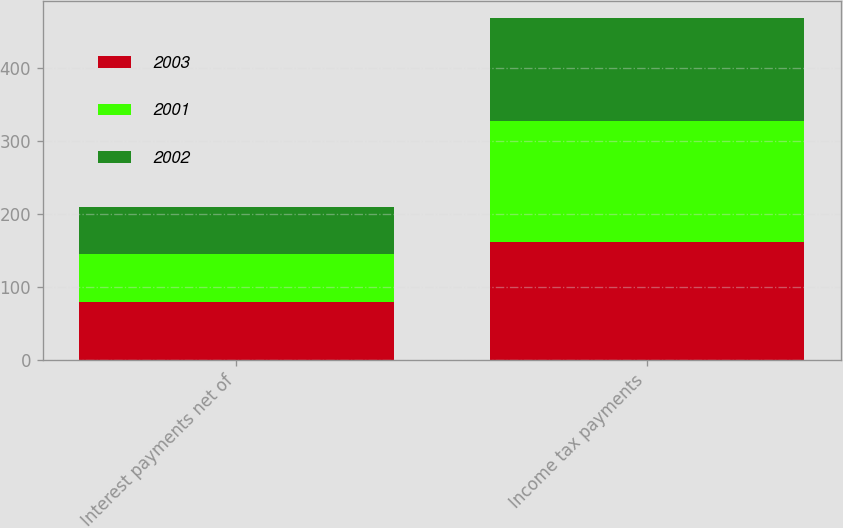<chart> <loc_0><loc_0><loc_500><loc_500><stacked_bar_chart><ecel><fcel>Interest payments net of<fcel>Income tax payments<nl><fcel>2003<fcel>79.5<fcel>161.3<nl><fcel>2001<fcel>64.5<fcel>165.1<nl><fcel>2002<fcel>65.2<fcel>141.7<nl></chart> 